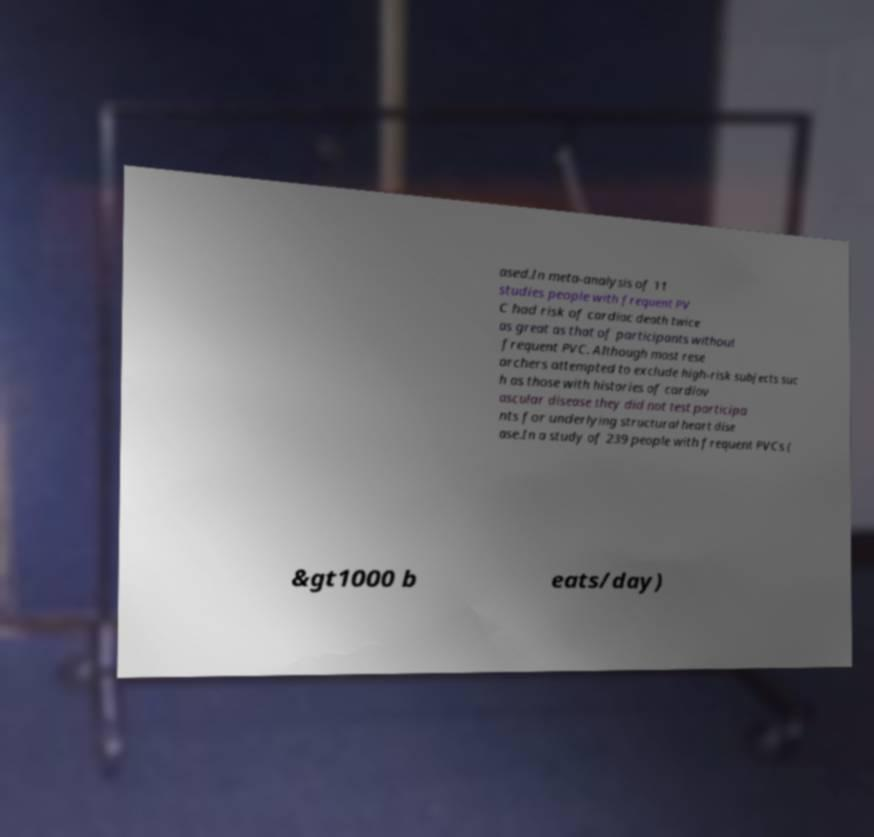Please read and relay the text visible in this image. What does it say? ased.In meta-analysis of 11 studies people with frequent PV C had risk of cardiac death twice as great as that of participants without frequent PVC. Although most rese archers attempted to exclude high-risk subjects suc h as those with histories of cardiov ascular disease they did not test participa nts for underlying structural heart dise ase.In a study of 239 people with frequent PVCs ( &gt1000 b eats/day) 